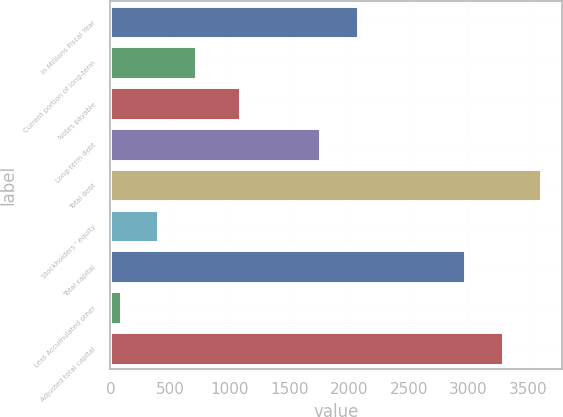Convert chart to OTSL. <chart><loc_0><loc_0><loc_500><loc_500><bar_chart><fcel>In Millions Fiscal Year<fcel>Current portion of long-term<fcel>Notes payable<fcel>Long-term debt<fcel>Total debt<fcel>Stockholders ' equity<fcel>Total capital<fcel>Less Accumulated other<fcel>Adjusted total capital<nl><fcel>2077.4<fcel>720.8<fcel>1086<fcel>1760<fcel>3605.8<fcel>403.4<fcel>2971<fcel>86<fcel>3288.4<nl></chart> 